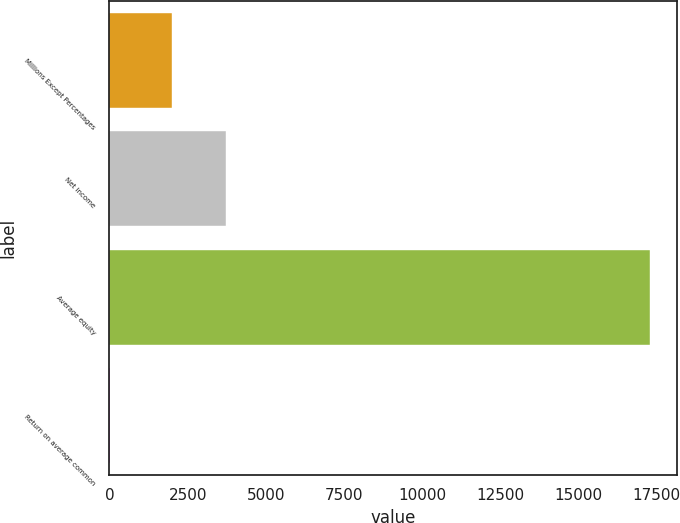<chart> <loc_0><loc_0><loc_500><loc_500><bar_chart><fcel>Millions Except Percentages<fcel>Net income<fcel>Average equity<fcel>Return on average common<nl><fcel>2010<fcel>3736.59<fcel>17282<fcel>16.1<nl></chart> 